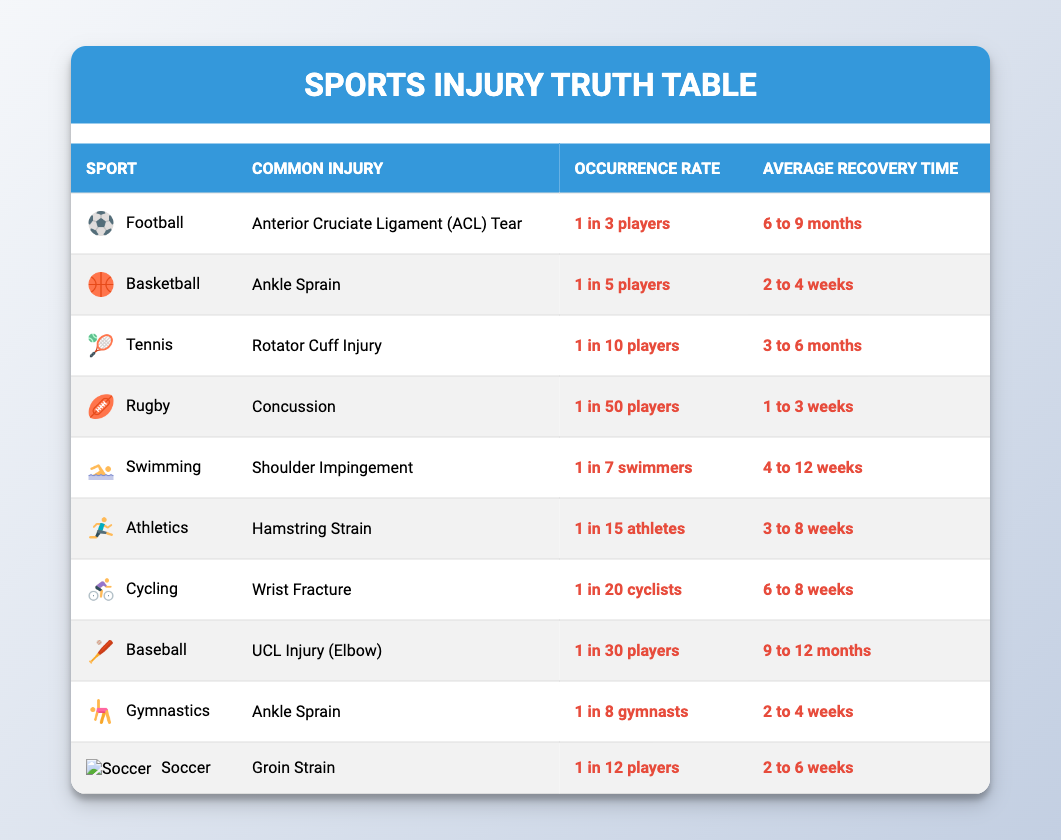What is the common injury for Basketball? The table indicates that the common injury for Basketball is an Ankle Sprain.
Answer: Ankle Sprain Which sport has the highest occurrence rate of injury? According to the table, Football has the highest occurrence rate of injury with 1 in 3 players affected.
Answer: Football What is the average recovery time for a Wrist Fracture? The table states that the average recovery time for a Wrist Fracture is 6 to 8 weeks.
Answer: 6 to 8 weeks Is the occurrence rate of injury in Soccer higher than in Rugby? By comparing the occurrence rates, Soccer has 1 in 12 players while Rugby has 1 in 50 players, hence Soccer's occurrence is higher.
Answer: Yes What is the average recovery time across all sports in the table? To find the average recovery time, identify the recovery times: 6-9 months (Football), 2-4 weeks (Basketball), 3-6 months (Tennis), 1-3 weeks (Rugby), 4-12 weeks (Swimming), 3-8 weeks (Athletics), 6-8 weeks (Cycling), 9-12 months (Baseball), 2-4 weeks (Gymnastics), 2-6 weeks (Soccer). Converting months to weeks for standardization, the averages would be roughly: Football (7.5 months = 30 weeks), Tennis (4.5 months = 18 weeks), and Baseball (10.5 months = 42 weeks), and the rest are within 8-12 weeks. The total recovery time in weeks is 30 + 2 + 18 + 2 + 8 + 6 + 8 + 42 + 4 + 4 = 122 weeks for 10 sports. Thus, the average is 122 weeks / 10 = 12.2 weeks which is approximately 3 months.
Answer: Approximately 3 months How many sports listed have recovery times of 1 month or less? Reviewing the recovery times in the table reveals that Rugby (1-3 weeks), Basketball (2-4 weeks), Gymnastics (2-4 weeks), and Soccer (2-6 weeks) all have recovery times of 1 month or less. Hence, there are four sports that meet this criterion.
Answer: 4 Is there any sport where the average recovery time exceeds 10 months? The data shows that Baseball (9-12 months) and Football (6-9 months) are the only hereto with recovery times of 9 months or more, and Baseball's average recovery time can extend up to 12 months.
Answer: Yes What is the common injury for the sport with the best recovery time? The sport with the best recovery time, which is Rugby with an average recovery time of 1 to 3 weeks, has a common injury of Concussion.
Answer: Concussion Which sport has both a higher average recovery time proportionally to its occurrence rate? Examining the values, Baseball (occurrence rate 1 in 30 players) has an average recovery time of 9 to 12 months, while Football (1 in 3 players) has a recovery of 6 to 9 months; thus, Baseball exhibits a higher recovery time relative to its occurrence rate when both are compared.
Answer: Baseball 